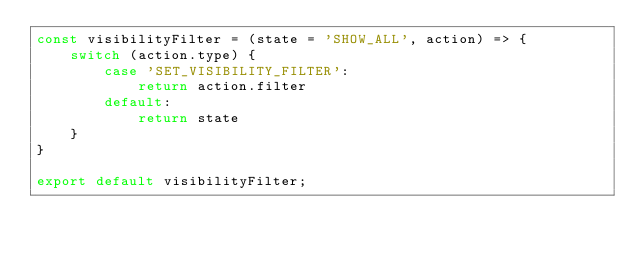Convert code to text. <code><loc_0><loc_0><loc_500><loc_500><_JavaScript_>const visibilityFilter = (state = 'SHOW_ALL', action) => {
    switch (action.type) {
        case 'SET_VISIBILITY_FILTER':
            return action.filter
        default:
            return state
    }
}

export default visibilityFilter;
</code> 